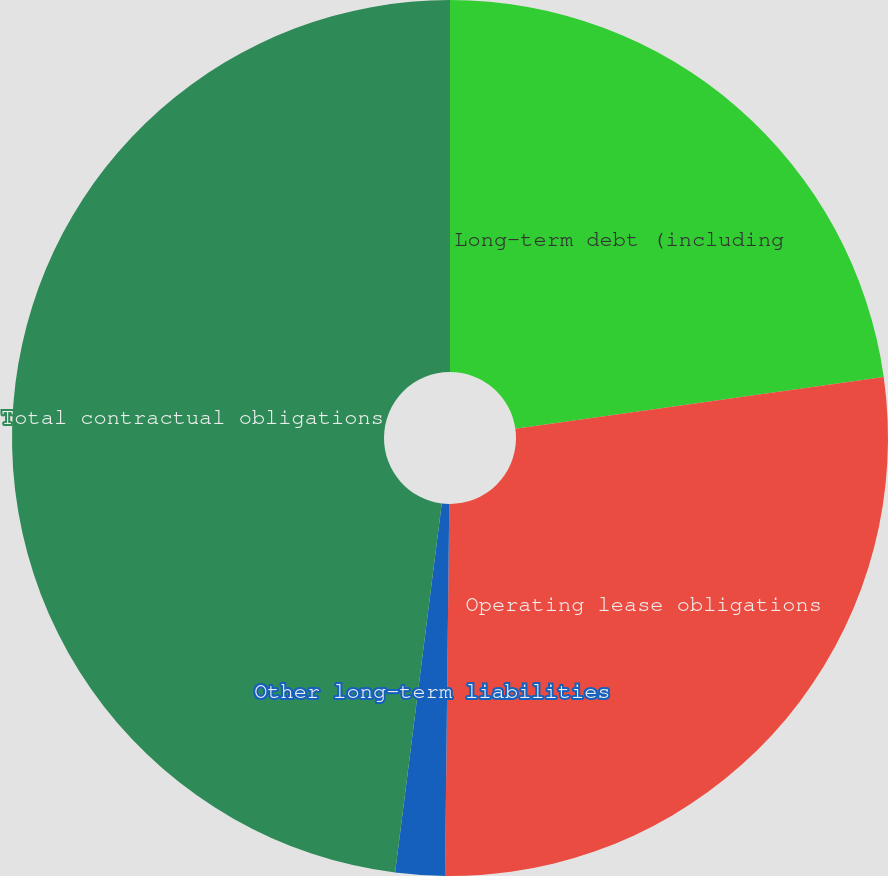Convert chart. <chart><loc_0><loc_0><loc_500><loc_500><pie_chart><fcel>Long-term debt (including<fcel>Operating lease obligations<fcel>Other long-term liabilities<fcel>Total contractual obligations<nl><fcel>22.78%<fcel>27.4%<fcel>1.82%<fcel>48.0%<nl></chart> 